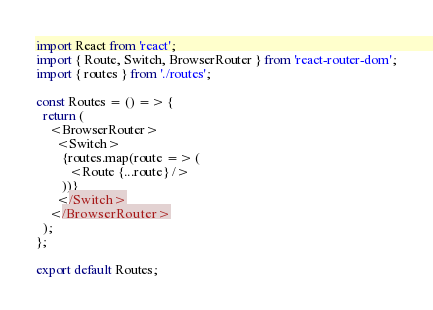Convert code to text. <code><loc_0><loc_0><loc_500><loc_500><_JavaScript_>import React from 'react';
import { Route, Switch, BrowserRouter } from 'react-router-dom';
import { routes } from './routes';

const Routes = () => {
  return (
    <BrowserRouter>
      <Switch>
        {routes.map(route => (
          <Route {...route} />
        ))}
      </Switch>
    </BrowserRouter>
  );
};

export default Routes;
</code> 